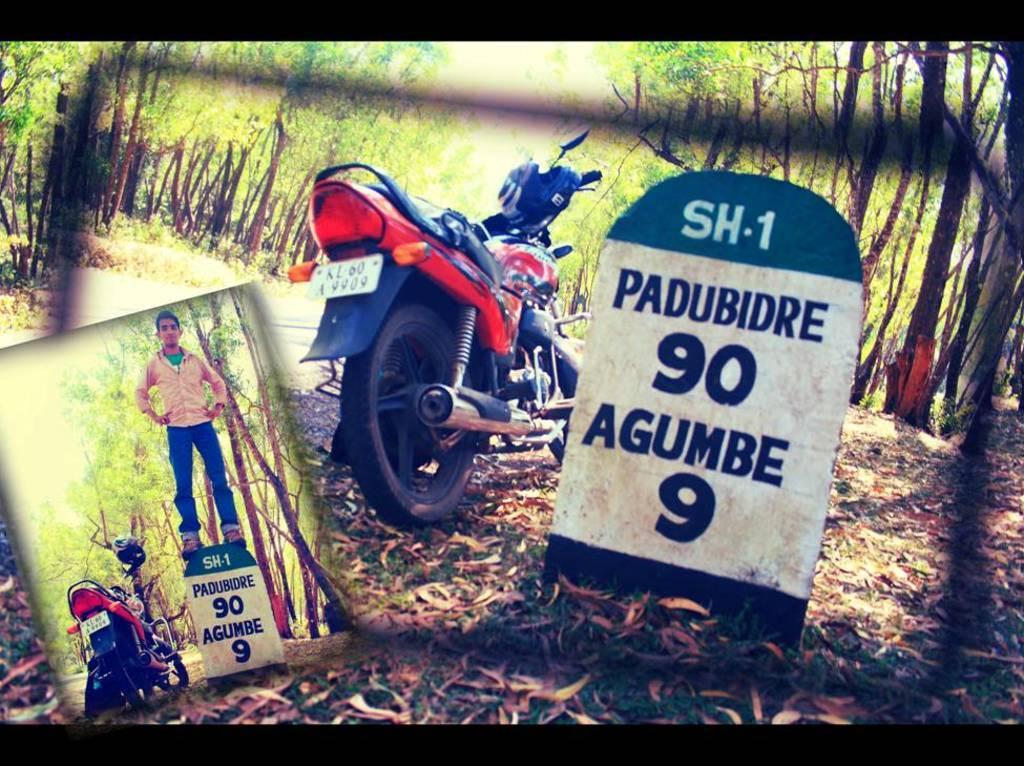Can you describe this image briefly? This is an edited image in one image there is bike and there is a mile stone, on that mile stone a man is standing, in the background there are trees, in another image there is a bike, beside that there is a milestone on either sides there are trees. 